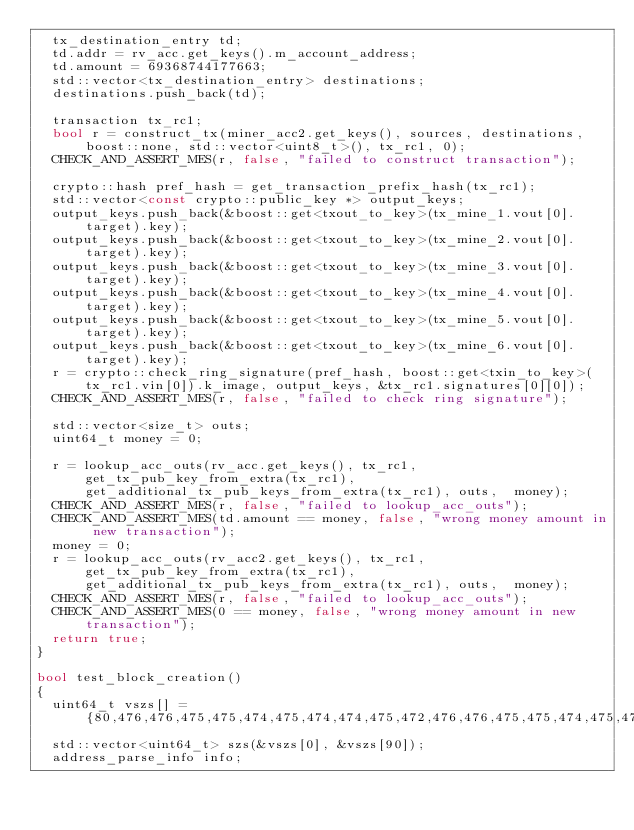Convert code to text. <code><loc_0><loc_0><loc_500><loc_500><_C++_>  tx_destination_entry td;
  td.addr = rv_acc.get_keys().m_account_address;
  td.amount = 69368744177663;
  std::vector<tx_destination_entry> destinations;
  destinations.push_back(td);

  transaction tx_rc1;
  bool r = construct_tx(miner_acc2.get_keys(), sources, destinations, boost::none, std::vector<uint8_t>(), tx_rc1, 0);
  CHECK_AND_ASSERT_MES(r, false, "failed to construct transaction");

  crypto::hash pref_hash = get_transaction_prefix_hash(tx_rc1);
  std::vector<const crypto::public_key *> output_keys;
  output_keys.push_back(&boost::get<txout_to_key>(tx_mine_1.vout[0].target).key);
  output_keys.push_back(&boost::get<txout_to_key>(tx_mine_2.vout[0].target).key);
  output_keys.push_back(&boost::get<txout_to_key>(tx_mine_3.vout[0].target).key);
  output_keys.push_back(&boost::get<txout_to_key>(tx_mine_4.vout[0].target).key);
  output_keys.push_back(&boost::get<txout_to_key>(tx_mine_5.vout[0].target).key);
  output_keys.push_back(&boost::get<txout_to_key>(tx_mine_6.vout[0].target).key);
  r = crypto::check_ring_signature(pref_hash, boost::get<txin_to_key>(tx_rc1.vin[0]).k_image, output_keys, &tx_rc1.signatures[0][0]);
  CHECK_AND_ASSERT_MES(r, false, "failed to check ring signature");

  std::vector<size_t> outs;
  uint64_t money = 0;

  r = lookup_acc_outs(rv_acc.get_keys(), tx_rc1, get_tx_pub_key_from_extra(tx_rc1), get_additional_tx_pub_keys_from_extra(tx_rc1), outs,  money);
  CHECK_AND_ASSERT_MES(r, false, "failed to lookup_acc_outs");
  CHECK_AND_ASSERT_MES(td.amount == money, false, "wrong money amount in new transaction");
  money = 0;
  r = lookup_acc_outs(rv_acc2.get_keys(), tx_rc1, get_tx_pub_key_from_extra(tx_rc1), get_additional_tx_pub_keys_from_extra(tx_rc1), outs,  money);
  CHECK_AND_ASSERT_MES(r, false, "failed to lookup_acc_outs");
  CHECK_AND_ASSERT_MES(0 == money, false, "wrong money amount in new transaction");
  return true;
}

bool test_block_creation()
{
  uint64_t vszs[] = {80,476,476,475,475,474,475,474,474,475,472,476,476,475,475,474,475,474,474,475,472,476,476,475,475,474,475,474,474,475,9391,476,476,475,475,474,475,8819,8301,475,472,4302,5316,14347,16620,19583,19403,19728,19442,19852,19015,19000,19016,19795,19749,18087,19787,19704,19750,19267,19006,19050,19445,19407,19522,19546,19788,19369,19486,19329,19370,18853,19600,19110,19320,19746,19474,19474,19743,19494,19755,19715,19769,19620,19368,19839,19532,23424,28287,30707};
  std::vector<uint64_t> szs(&vszs[0], &vszs[90]);
  address_parse_info info;</code> 